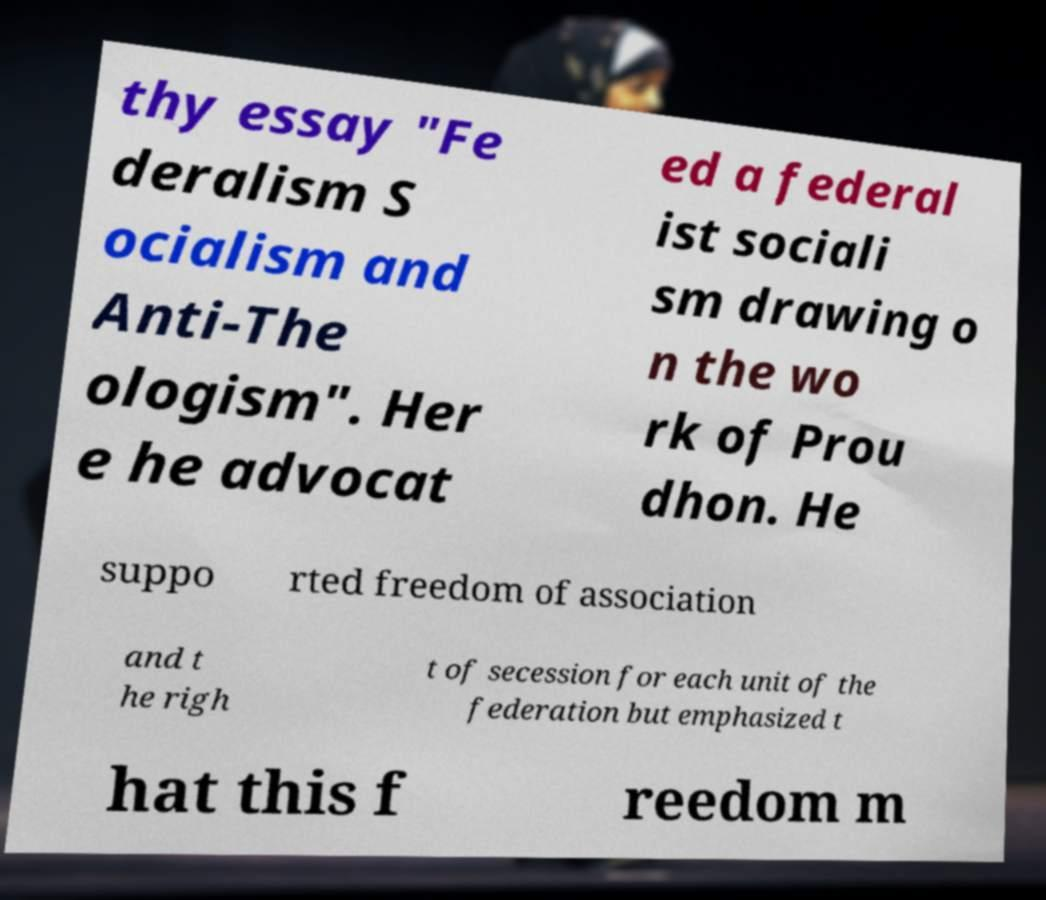I need the written content from this picture converted into text. Can you do that? thy essay "Fe deralism S ocialism and Anti-The ologism". Her e he advocat ed a federal ist sociali sm drawing o n the wo rk of Prou dhon. He suppo rted freedom of association and t he righ t of secession for each unit of the federation but emphasized t hat this f reedom m 